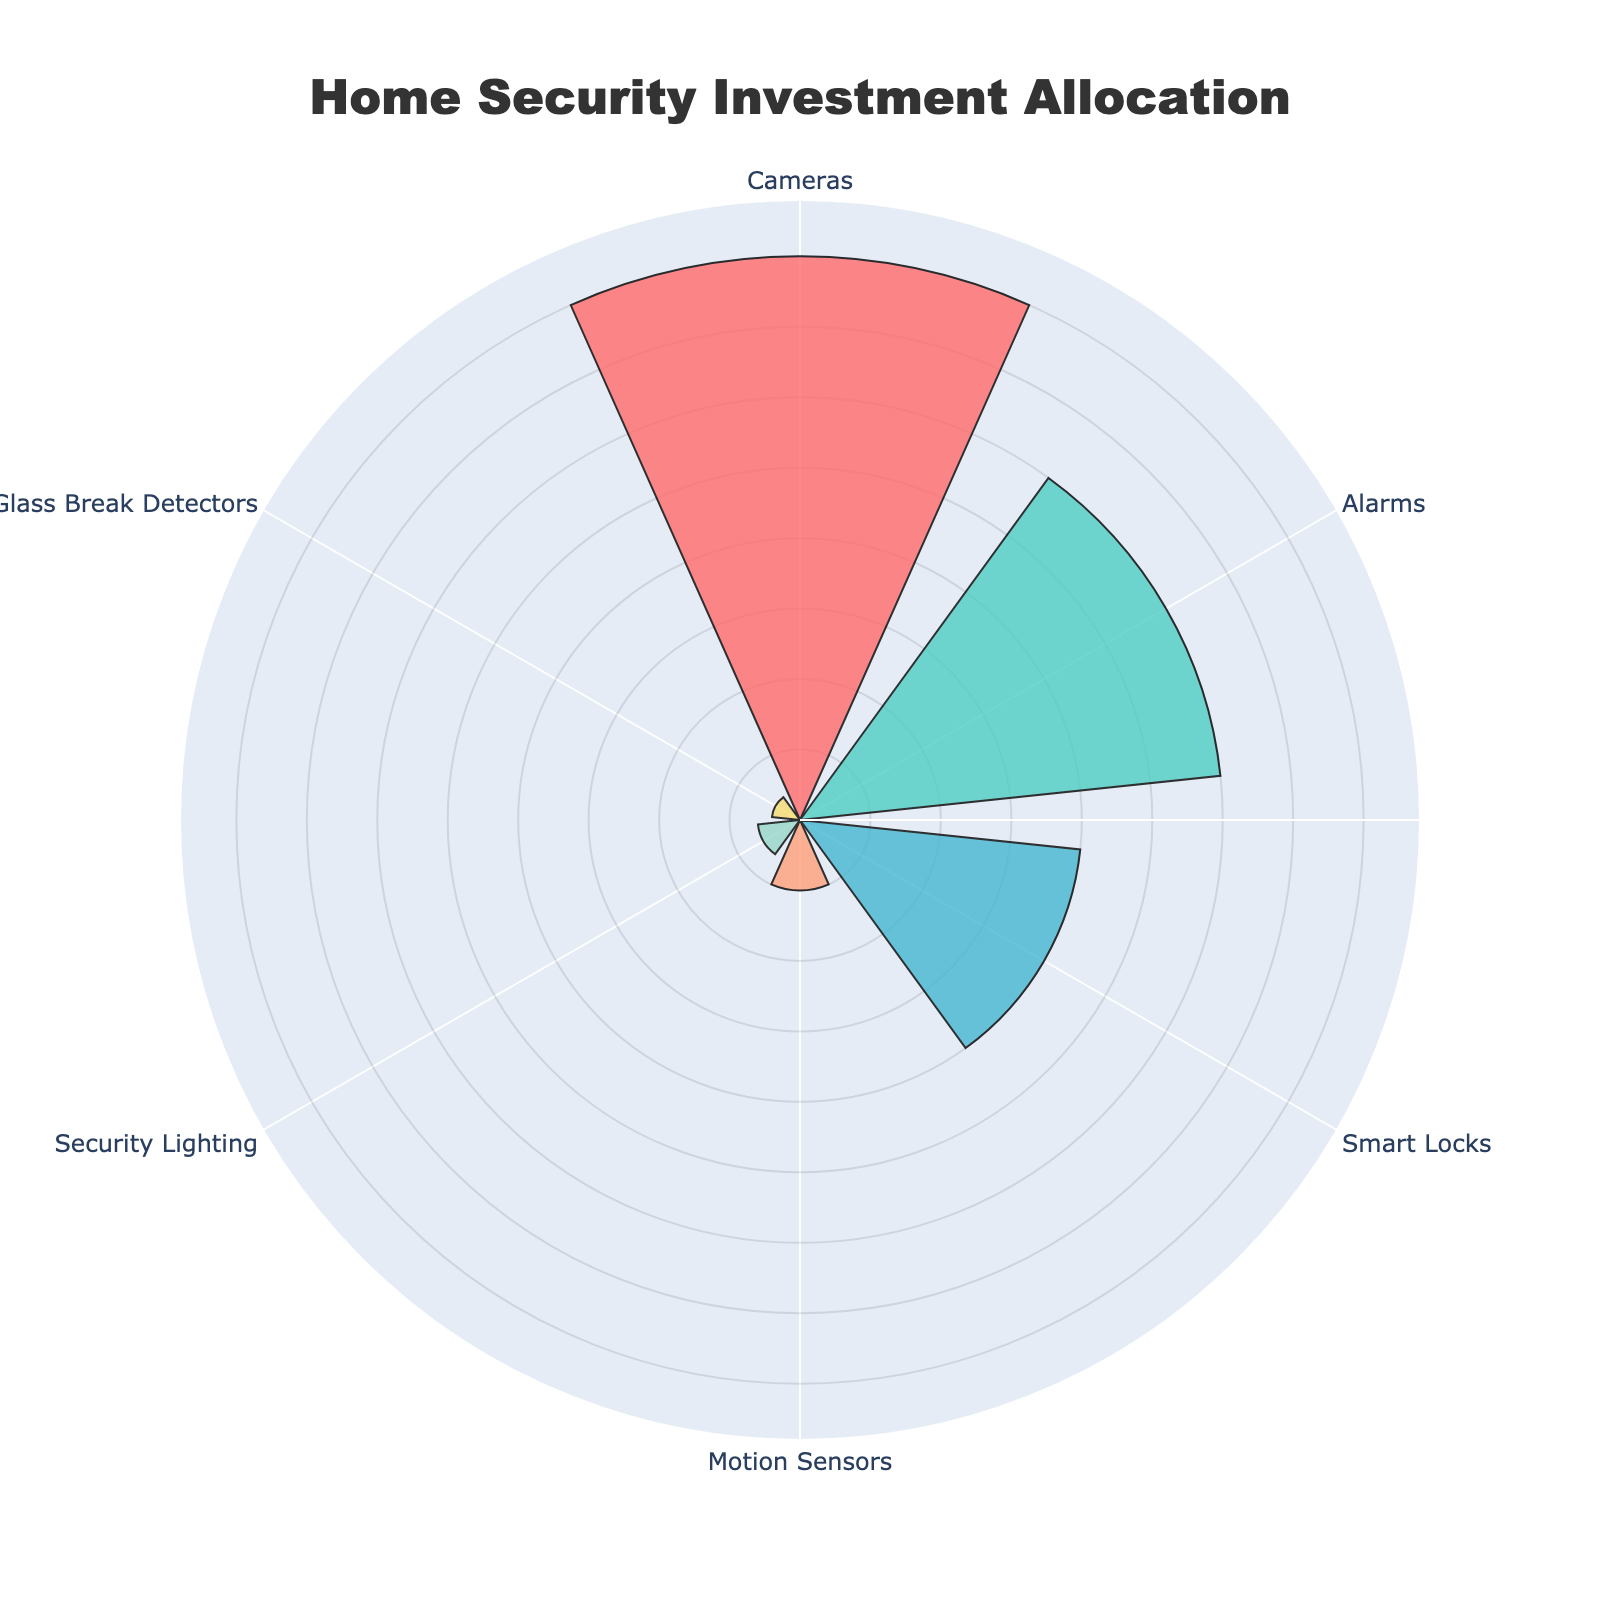What's the largest category in terms of percentage? By observing the lengths of the bars in the polar area chart, the Cameras category has the longest bar. Its percentage is 40%, which is visibly the largest.
Answer: Cameras Which category has the smallest proportion of investment? The smallest bar segment on the polar chart corresponds to Glass Break Detectors, which has the smallest percentage value of 2%.
Answer: Glass Break Detectors What is the sum of the investments in Cameras and Alarms? The Cameras segment is 40%, and the Alarms segment is 30%. Adding these together results in a total of 70%. 40% + 30% = 70%
Answer: 70% Which categories account for less than 10% of the investment each? Observing the polar area chart, the categories with proportions less than 10% are Motion Sensors (5%), Security Lighting (3%), and Glass Break Detectors (2%).
Answer: Motion Sensors, Security Lighting, Glass Break Detectors What's the percentage difference between Cameras and Smart Locks? The Cameras investment is 40%, and the Smart Locks investment is 20%. The difference between them is calculated as 40% - 20% = 20%.
Answer: 20% Is the percentage investment in Alarms higher or lower than that in Smart Locks? By comparing the lengths of the corresponding bars in the polar area chart, Alarms have an investment of 30%, which is higher than Smart Locks with 20%.
Answer: Higher What is the total percentage of investment in technologies other than Cameras? The total percentage of other technologies can be found by subtracting the Cameras' percentage from 100%. Other technologies collectively make up 60% (100% - 40%). Alternatively, summing up the individual percentages: Alarms (30%), Smart Locks (20%), Motion Sensors (5%), Security Lighting (3%), and Glass Break Detectors (2%) yields 60%.
Answer: 60% How many categories have higher investment percentages compared to Motion Sensors? Motion Sensors have a 5% proportion. By comparing this with other categories, the ones with higher percentages are Cameras (40%), Alarms (30%), and Smart Locks (20%).
Answer: 3 What's the range of the investment percentages? The maximum percentage is 40% (Cameras), and the minimum percentage is 2% (Glass Break Detectors). The range is calculated as 40% - 2% = 38%.
Answer: 38% 